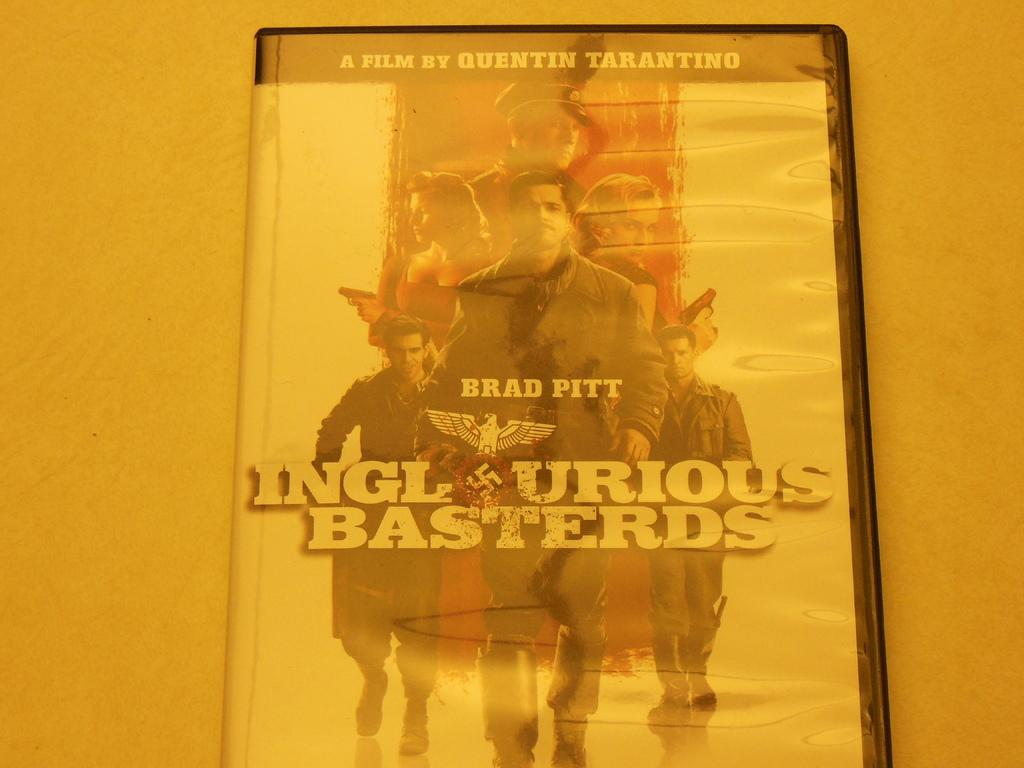What type of media is present in the image? There is a CD in the picture. What information can be found on the CD cover? The name of the film is printed on the CD cover, along with casting pictures. What time of day does the trip take place in the image? There is no trip or specific time of day mentioned or depicted in the image; it only shows a CD with a film name and casting pictures. 